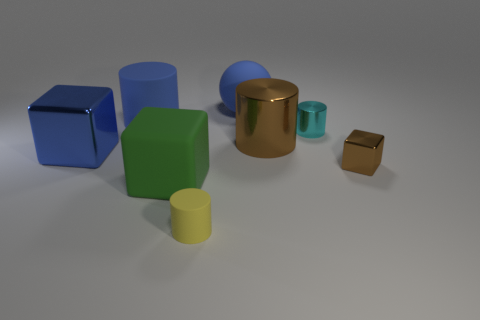Subtract all red cylinders. Subtract all blue balls. How many cylinders are left? 4 Add 1 cyan shiny cylinders. How many objects exist? 9 Subtract all blocks. How many objects are left? 5 Subtract all big blue objects. Subtract all purple metal cubes. How many objects are left? 5 Add 4 tiny yellow rubber things. How many tiny yellow rubber things are left? 5 Add 6 small cubes. How many small cubes exist? 7 Subtract 0 purple blocks. How many objects are left? 8 